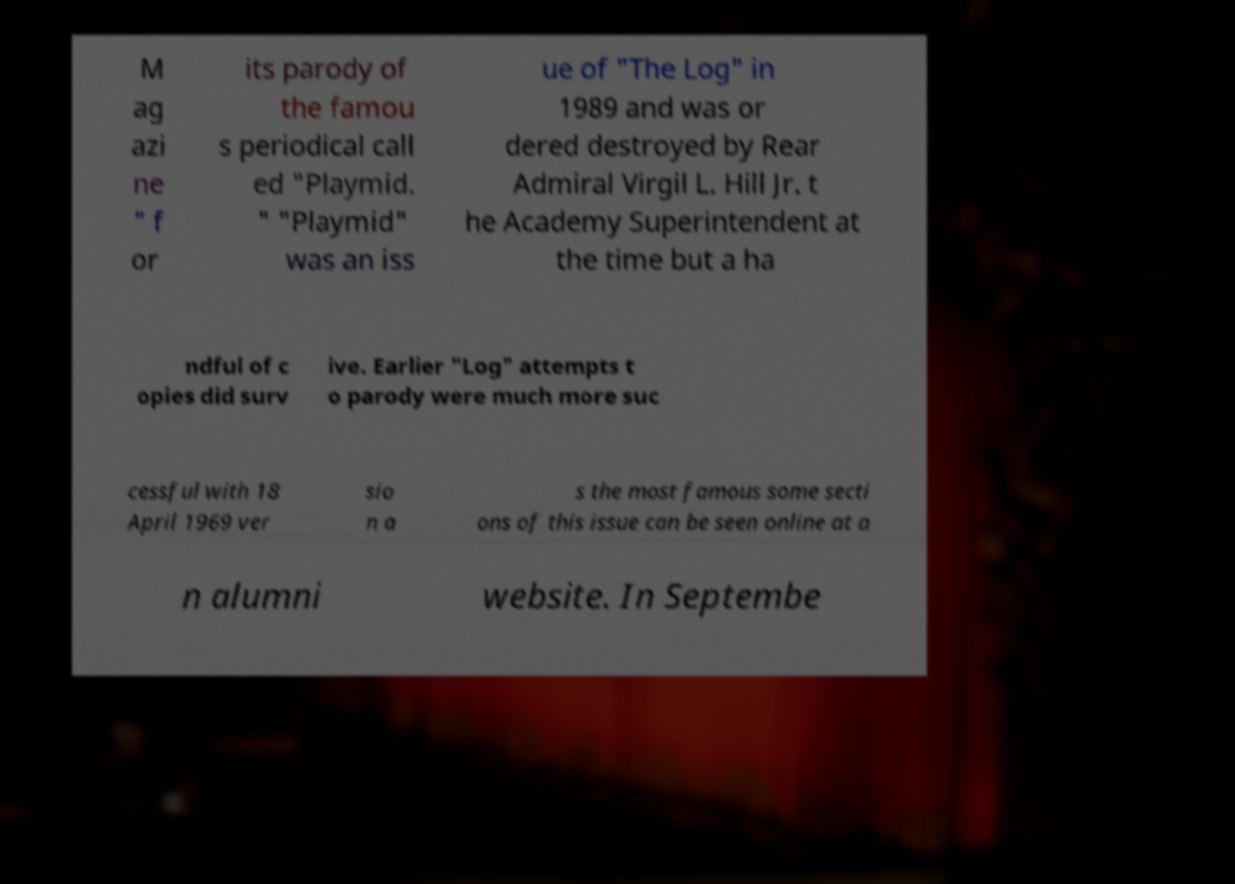What messages or text are displayed in this image? I need them in a readable, typed format. M ag azi ne " f or its parody of the famou s periodical call ed "Playmid. " "Playmid" was an iss ue of "The Log" in 1989 and was or dered destroyed by Rear Admiral Virgil L. Hill Jr. t he Academy Superintendent at the time but a ha ndful of c opies did surv ive. Earlier "Log" attempts t o parody were much more suc cessful with 18 April 1969 ver sio n a s the most famous some secti ons of this issue can be seen online at a n alumni website. In Septembe 